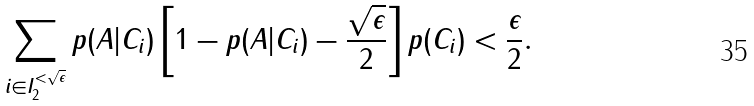Convert formula to latex. <formula><loc_0><loc_0><loc_500><loc_500>\sum _ { i \in I _ { 2 } ^ { < \sqrt { \epsilon } } } p ( A | C _ { i } ) \left [ 1 - p ( A | C _ { i } ) - \frac { \sqrt { \epsilon } } { 2 } \right ] p ( C _ { i } ) & < \frac { \epsilon } { 2 } .</formula> 